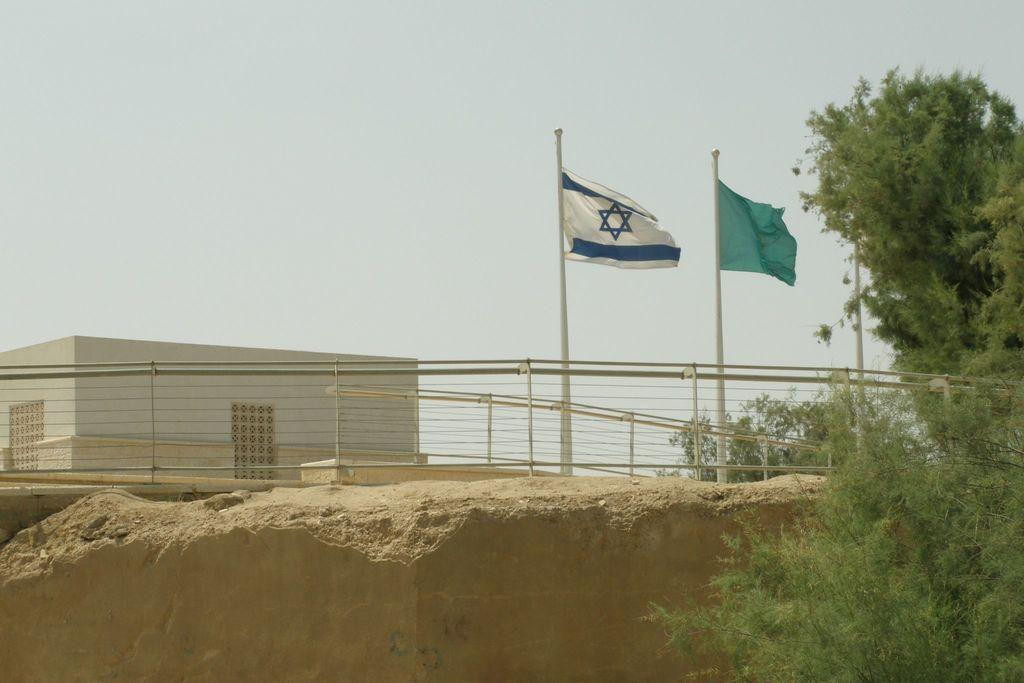What can be seen flying in the picture? There are flags in the picture. What type of structure is present in the picture? There is a building in the picture. What is separating the area in the picture? There is a fence in the picture. What type of vegetation is visible in the picture? There are trees in the picture. What can be seen in the distance in the picture? The sky is visible in the background of the picture. How many cows are grazing in the picture? There are no cows present in the picture. What type of record is being played in the background of the picture? There is no record being played in the picture; it features flags, a building, a fence, trees, and the sky. 